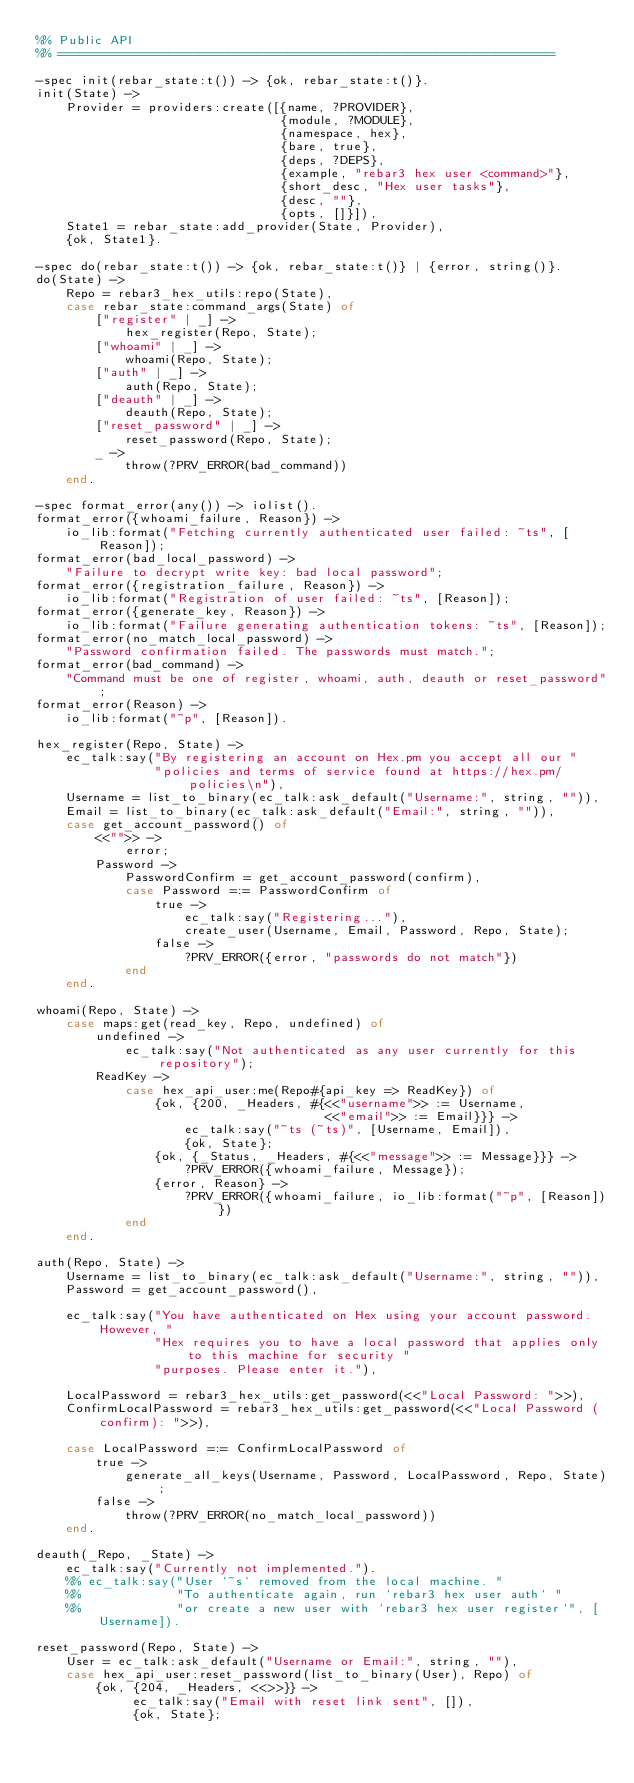<code> <loc_0><loc_0><loc_500><loc_500><_Erlang_>%% Public API
%% ===================================================================

-spec init(rebar_state:t()) -> {ok, rebar_state:t()}.
init(State) ->
    Provider = providers:create([{name, ?PROVIDER},
                                 {module, ?MODULE},
                                 {namespace, hex},
                                 {bare, true},
                                 {deps, ?DEPS},
                                 {example, "rebar3 hex user <command>"},
                                 {short_desc, "Hex user tasks"},
                                 {desc, ""},
                                 {opts, []}]),
    State1 = rebar_state:add_provider(State, Provider),
    {ok, State1}.

-spec do(rebar_state:t()) -> {ok, rebar_state:t()} | {error, string()}.
do(State) ->
    Repo = rebar3_hex_utils:repo(State),
    case rebar_state:command_args(State) of
        ["register" | _] ->
            hex_register(Repo, State);
        ["whoami" | _] ->
            whoami(Repo, State);
        ["auth" | _] ->
            auth(Repo, State);
        ["deauth" | _] ->
            deauth(Repo, State);
        ["reset_password" | _] ->
            reset_password(Repo, State);
        _ ->
            throw(?PRV_ERROR(bad_command))
    end.

-spec format_error(any()) -> iolist().
format_error({whoami_failure, Reason}) ->
    io_lib:format("Fetching currently authenticated user failed: ~ts", [Reason]);
format_error(bad_local_password) ->
    "Failure to decrypt write key: bad local password";
format_error({registration_failure, Reason}) ->
    io_lib:format("Registration of user failed: ~ts", [Reason]);
format_error({generate_key, Reason}) ->
    io_lib:format("Failure generating authentication tokens: ~ts", [Reason]);
format_error(no_match_local_password) ->
    "Password confirmation failed. The passwords must match.";
format_error(bad_command) ->
    "Command must be one of register, whoami, auth, deauth or reset_password";
format_error(Reason) ->
    io_lib:format("~p", [Reason]).

hex_register(Repo, State) ->
    ec_talk:say("By registering an account on Hex.pm you accept all our "
                "policies and terms of service found at https://hex.pm/policies\n"),
    Username = list_to_binary(ec_talk:ask_default("Username:", string, "")),
    Email = list_to_binary(ec_talk:ask_default("Email:", string, "")),
    case get_account_password() of
        <<"">> ->
            error;
        Password ->
            PasswordConfirm = get_account_password(confirm),
            case Password =:= PasswordConfirm of
                true ->
                    ec_talk:say("Registering..."),
                    create_user(Username, Email, Password, Repo, State);
                false ->
                    ?PRV_ERROR({error, "passwords do not match"})
            end
    end.

whoami(Repo, State) ->
    case maps:get(read_key, Repo, undefined) of
        undefined ->
            ec_talk:say("Not authenticated as any user currently for this repository");
        ReadKey ->
            case hex_api_user:me(Repo#{api_key => ReadKey}) of
                {ok, {200, _Headers, #{<<"username">> := Username,
                                       <<"email">> := Email}}} ->
                    ec_talk:say("~ts (~ts)", [Username, Email]),
                    {ok, State};
                {ok, {_Status, _Headers, #{<<"message">> := Message}}} ->
                    ?PRV_ERROR({whoami_failure, Message});
                {error, Reason} ->
                    ?PRV_ERROR({whoami_failure, io_lib:format("~p", [Reason])})
            end
    end.

auth(Repo, State) ->
    Username = list_to_binary(ec_talk:ask_default("Username:", string, "")),
    Password = get_account_password(),

    ec_talk:say("You have authenticated on Hex using your account password. However, "
                "Hex requires you to have a local password that applies only to this machine for security "
                "purposes. Please enter it."),

    LocalPassword = rebar3_hex_utils:get_password(<<"Local Password: ">>),
    ConfirmLocalPassword = rebar3_hex_utils:get_password(<<"Local Password (confirm): ">>),

    case LocalPassword =:= ConfirmLocalPassword of
        true ->
            generate_all_keys(Username, Password, LocalPassword, Repo, State);
        false ->
            throw(?PRV_ERROR(no_match_local_password))
    end.

deauth(_Repo, _State) ->
    ec_talk:say("Currently not implemented.").
    %% ec_talk:say("User `~s` removed from the local machine. "
    %%             "To authenticate again, run `rebar3 hex user auth` "
    %%             "or create a new user with `rebar3 hex user register`", [Username]).

reset_password(Repo, State) ->
    User = ec_talk:ask_default("Username or Email:", string, ""),
    case hex_api_user:reset_password(list_to_binary(User), Repo) of
        {ok, {204, _Headers, <<>>}} ->
             ec_talk:say("Email with reset link sent", []),
             {ok, State};</code> 